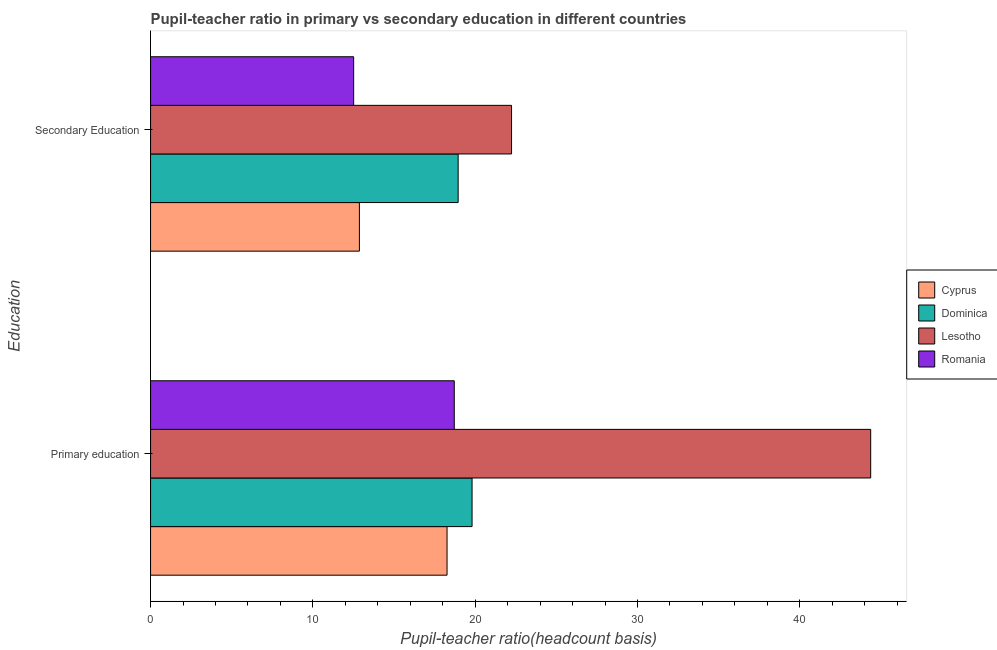Are the number of bars on each tick of the Y-axis equal?
Offer a very short reply. Yes. How many bars are there on the 2nd tick from the top?
Provide a short and direct response. 4. What is the label of the 2nd group of bars from the top?
Your response must be concise. Primary education. What is the pupil teacher ratio on secondary education in Romania?
Offer a terse response. 12.51. Across all countries, what is the maximum pupil teacher ratio on secondary education?
Offer a terse response. 22.24. Across all countries, what is the minimum pupil-teacher ratio in primary education?
Give a very brief answer. 18.27. In which country was the pupil-teacher ratio in primary education maximum?
Provide a succinct answer. Lesotho. In which country was the pupil-teacher ratio in primary education minimum?
Provide a short and direct response. Cyprus. What is the total pupil teacher ratio on secondary education in the graph?
Give a very brief answer. 66.57. What is the difference between the pupil-teacher ratio in primary education in Romania and that in Dominica?
Offer a terse response. -1.1. What is the difference between the pupil teacher ratio on secondary education in Lesotho and the pupil-teacher ratio in primary education in Cyprus?
Offer a terse response. 3.97. What is the average pupil teacher ratio on secondary education per country?
Offer a very short reply. 16.64. What is the difference between the pupil teacher ratio on secondary education and pupil-teacher ratio in primary education in Cyprus?
Ensure brevity in your answer.  -5.4. In how many countries, is the pupil-teacher ratio in primary education greater than 34 ?
Your answer should be very brief. 1. What is the ratio of the pupil teacher ratio on secondary education in Lesotho to that in Romania?
Your answer should be very brief. 1.78. Is the pupil-teacher ratio in primary education in Lesotho less than that in Romania?
Give a very brief answer. No. In how many countries, is the pupil teacher ratio on secondary education greater than the average pupil teacher ratio on secondary education taken over all countries?
Provide a succinct answer. 2. What does the 4th bar from the top in Primary education represents?
Give a very brief answer. Cyprus. What does the 3rd bar from the bottom in Primary education represents?
Provide a short and direct response. Lesotho. How many countries are there in the graph?
Keep it short and to the point. 4. What is the difference between two consecutive major ticks on the X-axis?
Ensure brevity in your answer.  10. Are the values on the major ticks of X-axis written in scientific E-notation?
Ensure brevity in your answer.  No. Does the graph contain grids?
Keep it short and to the point. No. Where does the legend appear in the graph?
Give a very brief answer. Center right. How many legend labels are there?
Offer a very short reply. 4. What is the title of the graph?
Offer a terse response. Pupil-teacher ratio in primary vs secondary education in different countries. What is the label or title of the X-axis?
Give a very brief answer. Pupil-teacher ratio(headcount basis). What is the label or title of the Y-axis?
Offer a very short reply. Education. What is the Pupil-teacher ratio(headcount basis) in Cyprus in Primary education?
Provide a short and direct response. 18.27. What is the Pupil-teacher ratio(headcount basis) in Dominica in Primary education?
Your response must be concise. 19.81. What is the Pupil-teacher ratio(headcount basis) of Lesotho in Primary education?
Your answer should be very brief. 44.37. What is the Pupil-teacher ratio(headcount basis) in Romania in Primary education?
Offer a terse response. 18.71. What is the Pupil-teacher ratio(headcount basis) of Cyprus in Secondary Education?
Make the answer very short. 12.87. What is the Pupil-teacher ratio(headcount basis) of Dominica in Secondary Education?
Your answer should be compact. 18.95. What is the Pupil-teacher ratio(headcount basis) of Lesotho in Secondary Education?
Provide a succinct answer. 22.24. What is the Pupil-teacher ratio(headcount basis) in Romania in Secondary Education?
Provide a short and direct response. 12.51. Across all Education, what is the maximum Pupil-teacher ratio(headcount basis) in Cyprus?
Your response must be concise. 18.27. Across all Education, what is the maximum Pupil-teacher ratio(headcount basis) of Dominica?
Offer a very short reply. 19.81. Across all Education, what is the maximum Pupil-teacher ratio(headcount basis) in Lesotho?
Provide a succinct answer. 44.37. Across all Education, what is the maximum Pupil-teacher ratio(headcount basis) in Romania?
Offer a terse response. 18.71. Across all Education, what is the minimum Pupil-teacher ratio(headcount basis) in Cyprus?
Keep it short and to the point. 12.87. Across all Education, what is the minimum Pupil-teacher ratio(headcount basis) of Dominica?
Provide a short and direct response. 18.95. Across all Education, what is the minimum Pupil-teacher ratio(headcount basis) of Lesotho?
Keep it short and to the point. 22.24. Across all Education, what is the minimum Pupil-teacher ratio(headcount basis) in Romania?
Your answer should be very brief. 12.51. What is the total Pupil-teacher ratio(headcount basis) in Cyprus in the graph?
Give a very brief answer. 31.14. What is the total Pupil-teacher ratio(headcount basis) of Dominica in the graph?
Keep it short and to the point. 38.76. What is the total Pupil-teacher ratio(headcount basis) in Lesotho in the graph?
Keep it short and to the point. 66.61. What is the total Pupil-teacher ratio(headcount basis) in Romania in the graph?
Provide a succinct answer. 31.23. What is the difference between the Pupil-teacher ratio(headcount basis) in Cyprus in Primary education and that in Secondary Education?
Provide a succinct answer. 5.4. What is the difference between the Pupil-teacher ratio(headcount basis) in Lesotho in Primary education and that in Secondary Education?
Provide a short and direct response. 22.13. What is the difference between the Pupil-teacher ratio(headcount basis) of Romania in Primary education and that in Secondary Education?
Your answer should be compact. 6.2. What is the difference between the Pupil-teacher ratio(headcount basis) in Cyprus in Primary education and the Pupil-teacher ratio(headcount basis) in Dominica in Secondary Education?
Make the answer very short. -0.68. What is the difference between the Pupil-teacher ratio(headcount basis) of Cyprus in Primary education and the Pupil-teacher ratio(headcount basis) of Lesotho in Secondary Education?
Give a very brief answer. -3.97. What is the difference between the Pupil-teacher ratio(headcount basis) in Cyprus in Primary education and the Pupil-teacher ratio(headcount basis) in Romania in Secondary Education?
Provide a succinct answer. 5.75. What is the difference between the Pupil-teacher ratio(headcount basis) in Dominica in Primary education and the Pupil-teacher ratio(headcount basis) in Lesotho in Secondary Education?
Give a very brief answer. -2.43. What is the difference between the Pupil-teacher ratio(headcount basis) in Dominica in Primary education and the Pupil-teacher ratio(headcount basis) in Romania in Secondary Education?
Your answer should be compact. 7.3. What is the difference between the Pupil-teacher ratio(headcount basis) in Lesotho in Primary education and the Pupil-teacher ratio(headcount basis) in Romania in Secondary Education?
Offer a very short reply. 31.86. What is the average Pupil-teacher ratio(headcount basis) of Cyprus per Education?
Give a very brief answer. 15.57. What is the average Pupil-teacher ratio(headcount basis) of Dominica per Education?
Make the answer very short. 19.38. What is the average Pupil-teacher ratio(headcount basis) of Lesotho per Education?
Your answer should be very brief. 33.31. What is the average Pupil-teacher ratio(headcount basis) in Romania per Education?
Offer a terse response. 15.61. What is the difference between the Pupil-teacher ratio(headcount basis) of Cyprus and Pupil-teacher ratio(headcount basis) of Dominica in Primary education?
Offer a terse response. -1.54. What is the difference between the Pupil-teacher ratio(headcount basis) of Cyprus and Pupil-teacher ratio(headcount basis) of Lesotho in Primary education?
Ensure brevity in your answer.  -26.1. What is the difference between the Pupil-teacher ratio(headcount basis) in Cyprus and Pupil-teacher ratio(headcount basis) in Romania in Primary education?
Your response must be concise. -0.44. What is the difference between the Pupil-teacher ratio(headcount basis) in Dominica and Pupil-teacher ratio(headcount basis) in Lesotho in Primary education?
Your response must be concise. -24.56. What is the difference between the Pupil-teacher ratio(headcount basis) of Dominica and Pupil-teacher ratio(headcount basis) of Romania in Primary education?
Give a very brief answer. 1.1. What is the difference between the Pupil-teacher ratio(headcount basis) of Lesotho and Pupil-teacher ratio(headcount basis) of Romania in Primary education?
Provide a succinct answer. 25.66. What is the difference between the Pupil-teacher ratio(headcount basis) in Cyprus and Pupil-teacher ratio(headcount basis) in Dominica in Secondary Education?
Provide a succinct answer. -6.08. What is the difference between the Pupil-teacher ratio(headcount basis) in Cyprus and Pupil-teacher ratio(headcount basis) in Lesotho in Secondary Education?
Your answer should be very brief. -9.37. What is the difference between the Pupil-teacher ratio(headcount basis) of Cyprus and Pupil-teacher ratio(headcount basis) of Romania in Secondary Education?
Your response must be concise. 0.35. What is the difference between the Pupil-teacher ratio(headcount basis) in Dominica and Pupil-teacher ratio(headcount basis) in Lesotho in Secondary Education?
Provide a short and direct response. -3.29. What is the difference between the Pupil-teacher ratio(headcount basis) in Dominica and Pupil-teacher ratio(headcount basis) in Romania in Secondary Education?
Keep it short and to the point. 6.44. What is the difference between the Pupil-teacher ratio(headcount basis) in Lesotho and Pupil-teacher ratio(headcount basis) in Romania in Secondary Education?
Offer a very short reply. 9.73. What is the ratio of the Pupil-teacher ratio(headcount basis) in Cyprus in Primary education to that in Secondary Education?
Your answer should be compact. 1.42. What is the ratio of the Pupil-teacher ratio(headcount basis) in Dominica in Primary education to that in Secondary Education?
Make the answer very short. 1.05. What is the ratio of the Pupil-teacher ratio(headcount basis) of Lesotho in Primary education to that in Secondary Education?
Your response must be concise. 1.99. What is the ratio of the Pupil-teacher ratio(headcount basis) in Romania in Primary education to that in Secondary Education?
Your answer should be compact. 1.5. What is the difference between the highest and the second highest Pupil-teacher ratio(headcount basis) in Cyprus?
Ensure brevity in your answer.  5.4. What is the difference between the highest and the second highest Pupil-teacher ratio(headcount basis) in Dominica?
Provide a short and direct response. 0.86. What is the difference between the highest and the second highest Pupil-teacher ratio(headcount basis) of Lesotho?
Provide a short and direct response. 22.13. What is the difference between the highest and the second highest Pupil-teacher ratio(headcount basis) in Romania?
Offer a terse response. 6.2. What is the difference between the highest and the lowest Pupil-teacher ratio(headcount basis) in Cyprus?
Your answer should be very brief. 5.4. What is the difference between the highest and the lowest Pupil-teacher ratio(headcount basis) of Lesotho?
Offer a very short reply. 22.13. What is the difference between the highest and the lowest Pupil-teacher ratio(headcount basis) of Romania?
Offer a terse response. 6.2. 